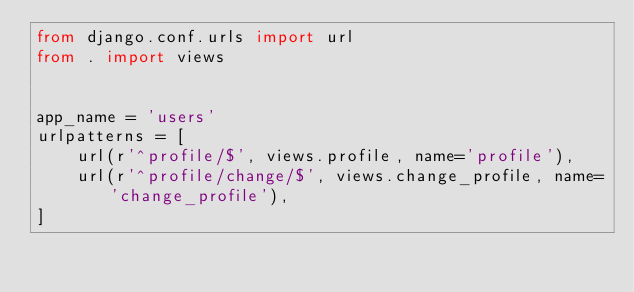Convert code to text. <code><loc_0><loc_0><loc_500><loc_500><_Python_>from django.conf.urls import url
from . import views


app_name = 'users'
urlpatterns = [
    url(r'^profile/$', views.profile, name='profile'),
    url(r'^profile/change/$', views.change_profile, name='change_profile'),
]</code> 